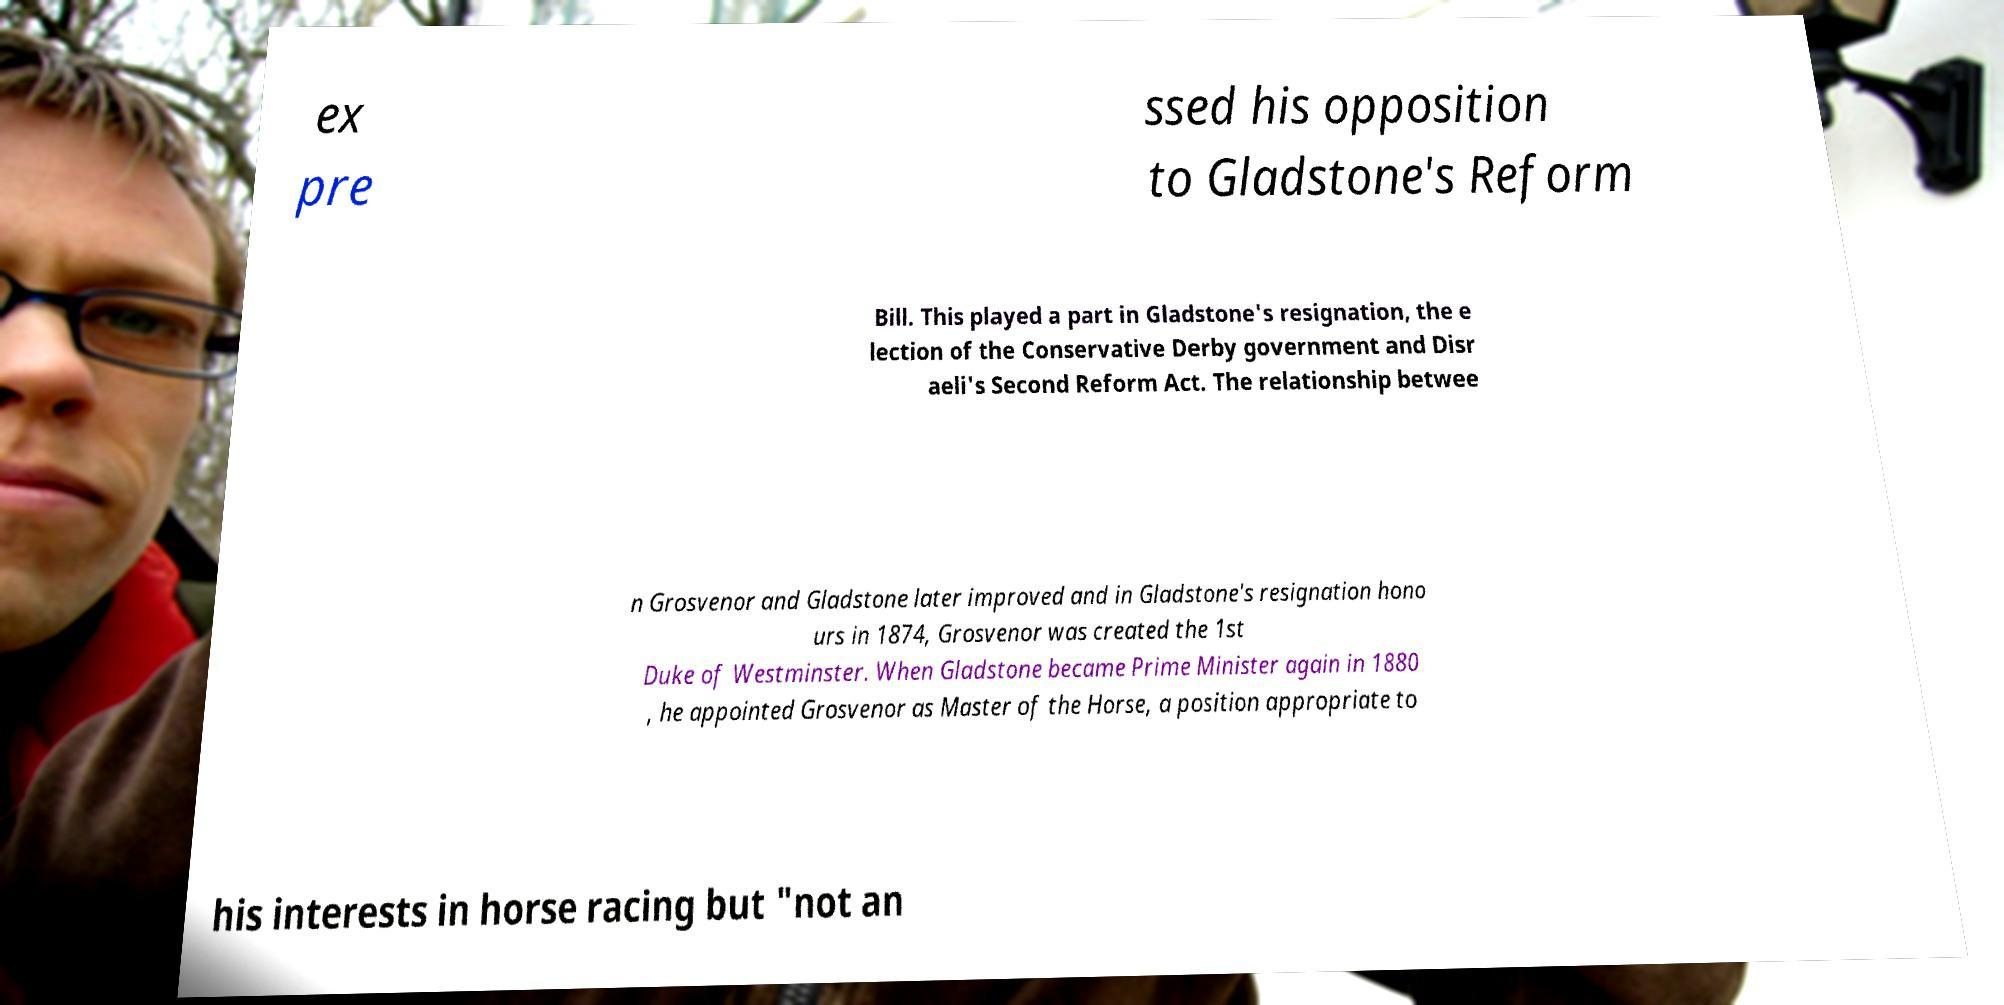Please identify and transcribe the text found in this image. ex pre ssed his opposition to Gladstone's Reform Bill. This played a part in Gladstone's resignation, the e lection of the Conservative Derby government and Disr aeli's Second Reform Act. The relationship betwee n Grosvenor and Gladstone later improved and in Gladstone's resignation hono urs in 1874, Grosvenor was created the 1st Duke of Westminster. When Gladstone became Prime Minister again in 1880 , he appointed Grosvenor as Master of the Horse, a position appropriate to his interests in horse racing but "not an 